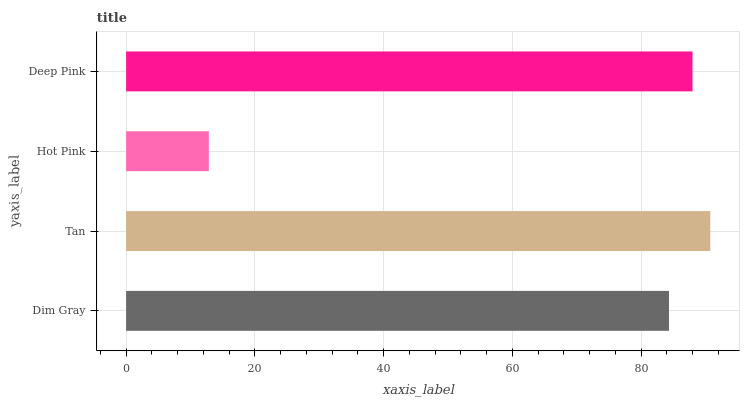Is Hot Pink the minimum?
Answer yes or no. Yes. Is Tan the maximum?
Answer yes or no. Yes. Is Tan the minimum?
Answer yes or no. No. Is Hot Pink the maximum?
Answer yes or no. No. Is Tan greater than Hot Pink?
Answer yes or no. Yes. Is Hot Pink less than Tan?
Answer yes or no. Yes. Is Hot Pink greater than Tan?
Answer yes or no. No. Is Tan less than Hot Pink?
Answer yes or no. No. Is Deep Pink the high median?
Answer yes or no. Yes. Is Dim Gray the low median?
Answer yes or no. Yes. Is Hot Pink the high median?
Answer yes or no. No. Is Deep Pink the low median?
Answer yes or no. No. 